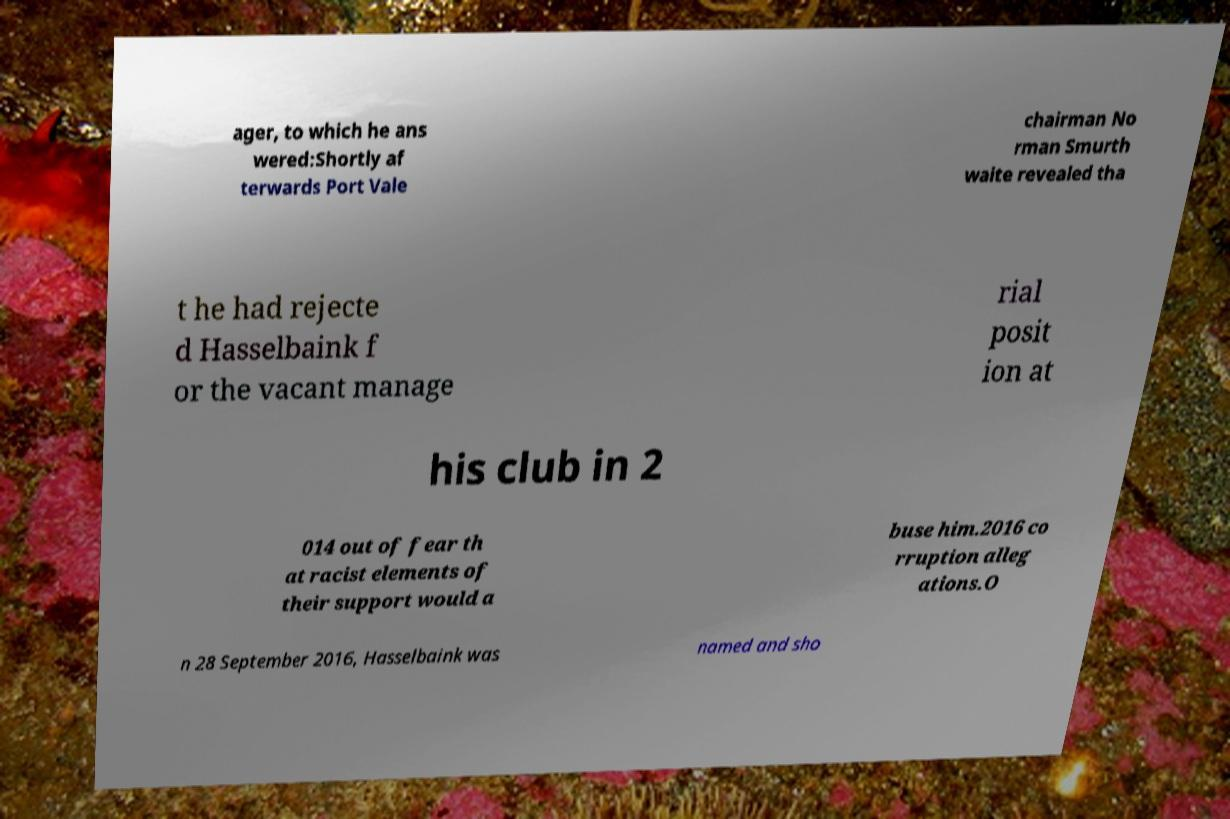What messages or text are displayed in this image? I need them in a readable, typed format. ager, to which he ans wered:Shortly af terwards Port Vale chairman No rman Smurth waite revealed tha t he had rejecte d Hasselbaink f or the vacant manage rial posit ion at his club in 2 014 out of fear th at racist elements of their support would a buse him.2016 co rruption alleg ations.O n 28 September 2016, Hasselbaink was named and sho 